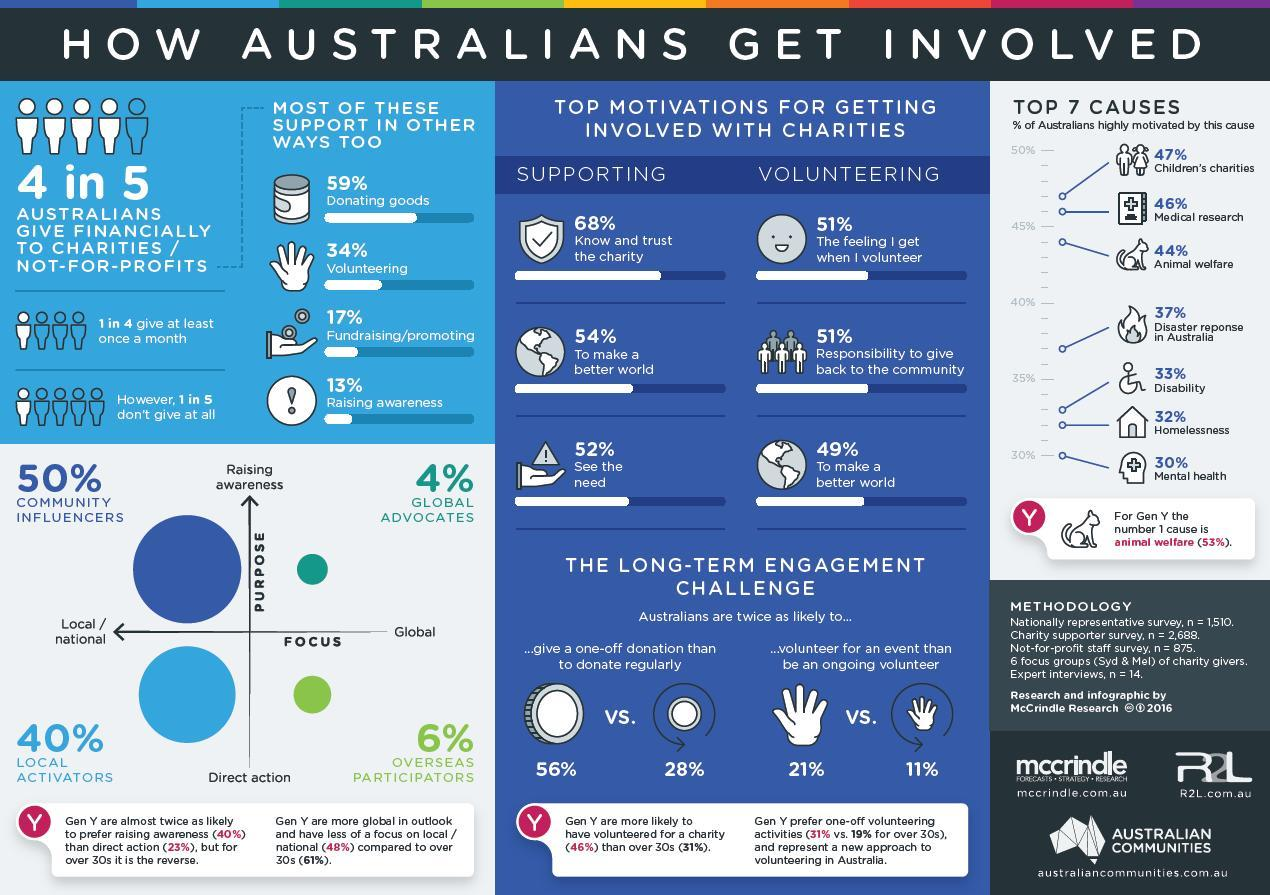What percentage of Australians volunteer for an event rather than being an ongoing volunteer?
Answer the question with a short phrase. 21% Which gender is highy motivated by the cause of animal welfare in Australia? Gen Y What percentage of community influencers are involved in raising awareness among Australians? 50% What percentage of Australians are involved in donating regularly? 28% What percentage of Australians are highly motivated by animal welfare? 44% What percentage of Australians are involved in raising awareness about giving financial help to charities? 13% What percentage of Australians donate goods to charities? 59% 